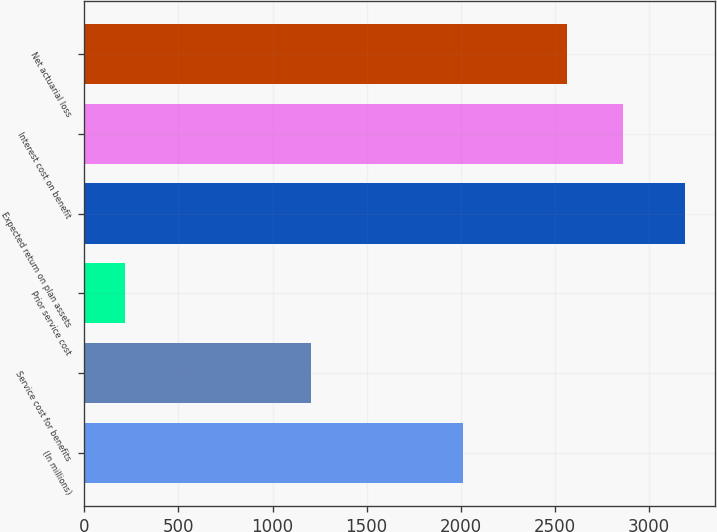Convert chart. <chart><loc_0><loc_0><loc_500><loc_500><bar_chart><fcel>(In millions)<fcel>Service cost for benefits<fcel>Prior service cost<fcel>Expected return on plan assets<fcel>Interest cost on benefit<fcel>Net actuarial loss<nl><fcel>2014<fcel>1205<fcel>214<fcel>3190<fcel>2862.6<fcel>2565<nl></chart> 